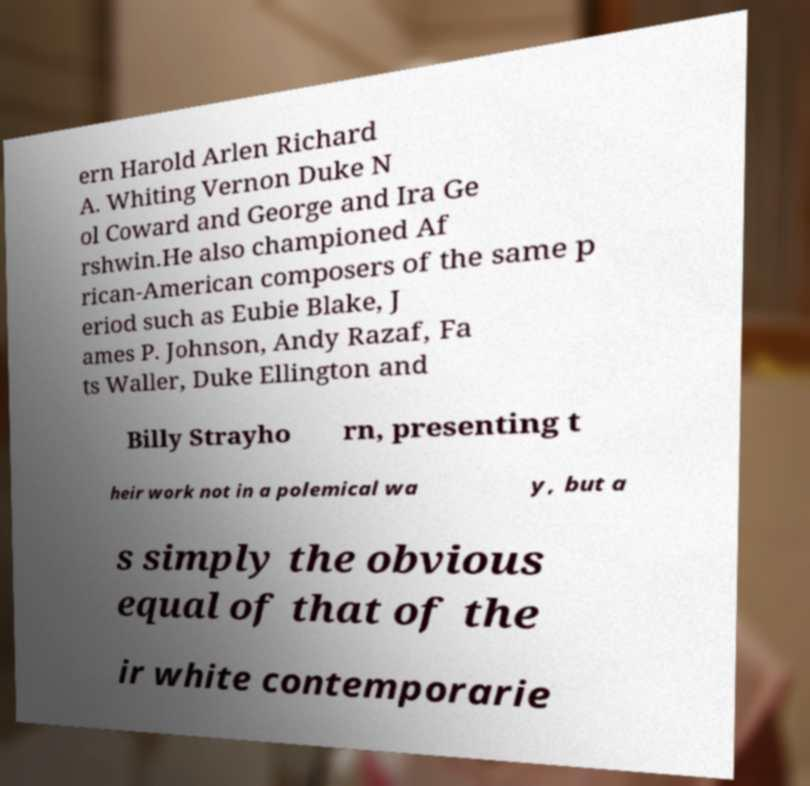Could you assist in decoding the text presented in this image and type it out clearly? ern Harold Arlen Richard A. Whiting Vernon Duke N ol Coward and George and Ira Ge rshwin.He also championed Af rican-American composers of the same p eriod such as Eubie Blake, J ames P. Johnson, Andy Razaf, Fa ts Waller, Duke Ellington and Billy Strayho rn, presenting t heir work not in a polemical wa y, but a s simply the obvious equal of that of the ir white contemporarie 